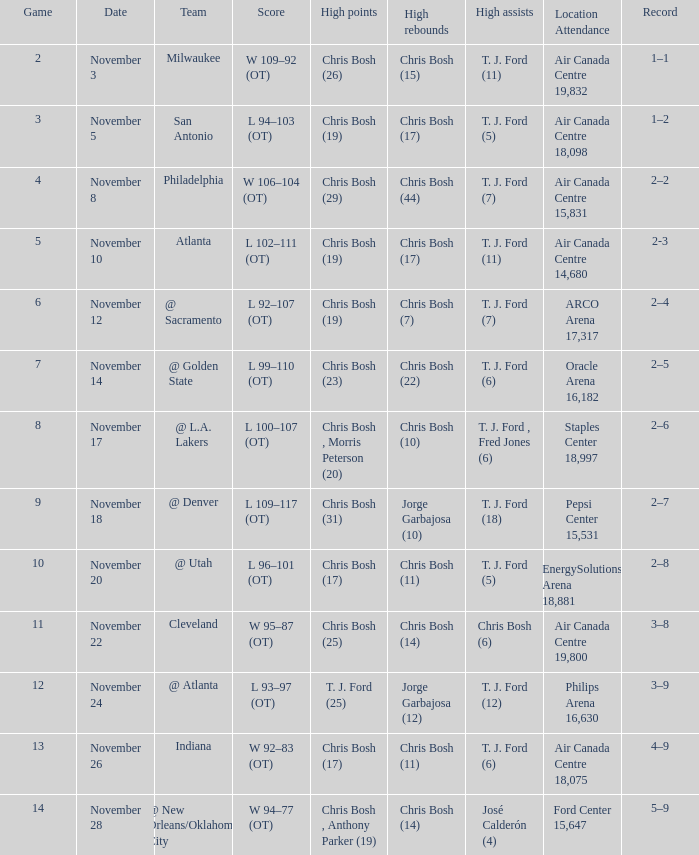Who tallied the highest points in game 4? Chris Bosh (29). 